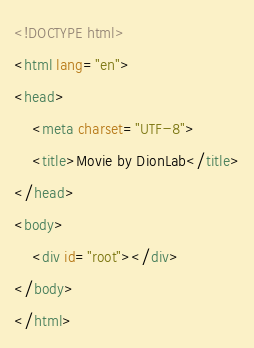Convert code to text. <code><loc_0><loc_0><loc_500><loc_500><_HTML_><!DOCTYPE html>
<html lang="en">
<head>
    <meta charset="UTF-8">
    <title>Movie by DionLab</title>
</head>
<body>
    <div id="root"></div>
</body>
</html></code> 